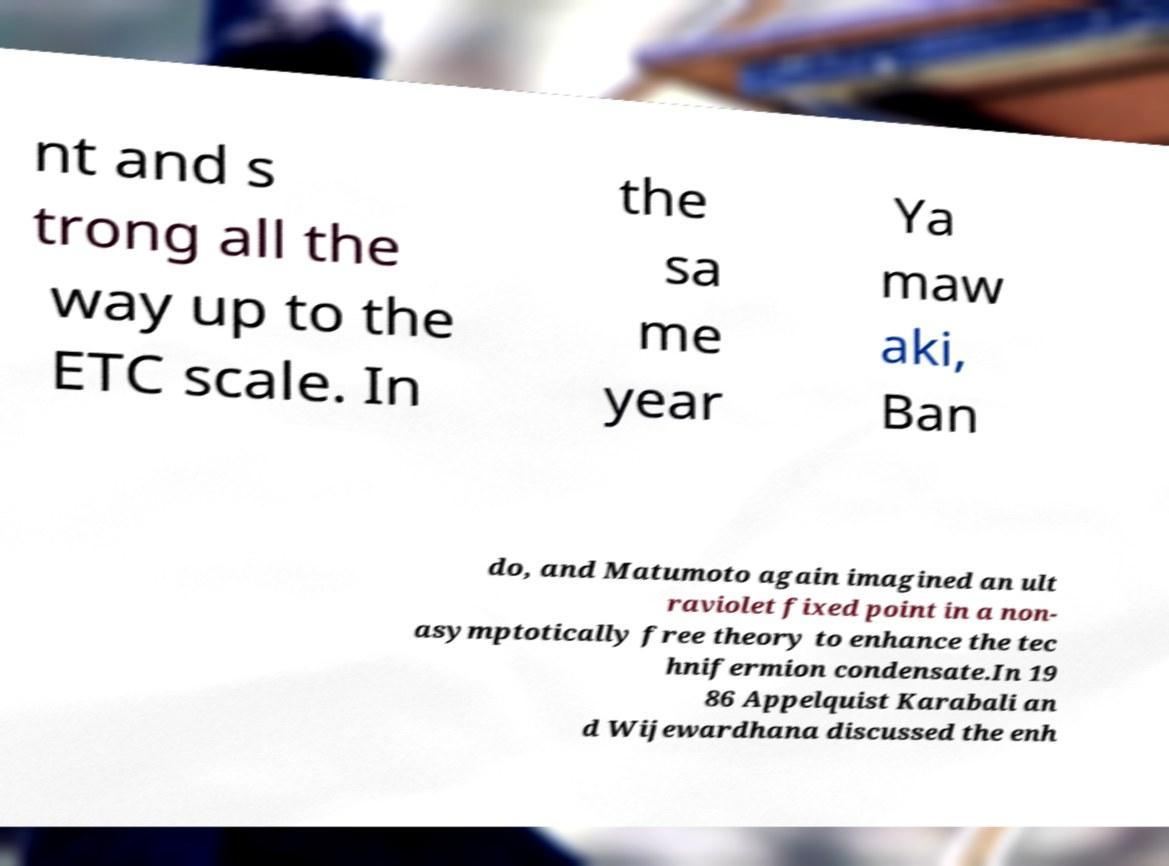What messages or text are displayed in this image? I need them in a readable, typed format. nt and s trong all the way up to the ETC scale. In the sa me year Ya maw aki, Ban do, and Matumoto again imagined an ult raviolet fixed point in a non- asymptotically free theory to enhance the tec hnifermion condensate.In 19 86 Appelquist Karabali an d Wijewardhana discussed the enh 